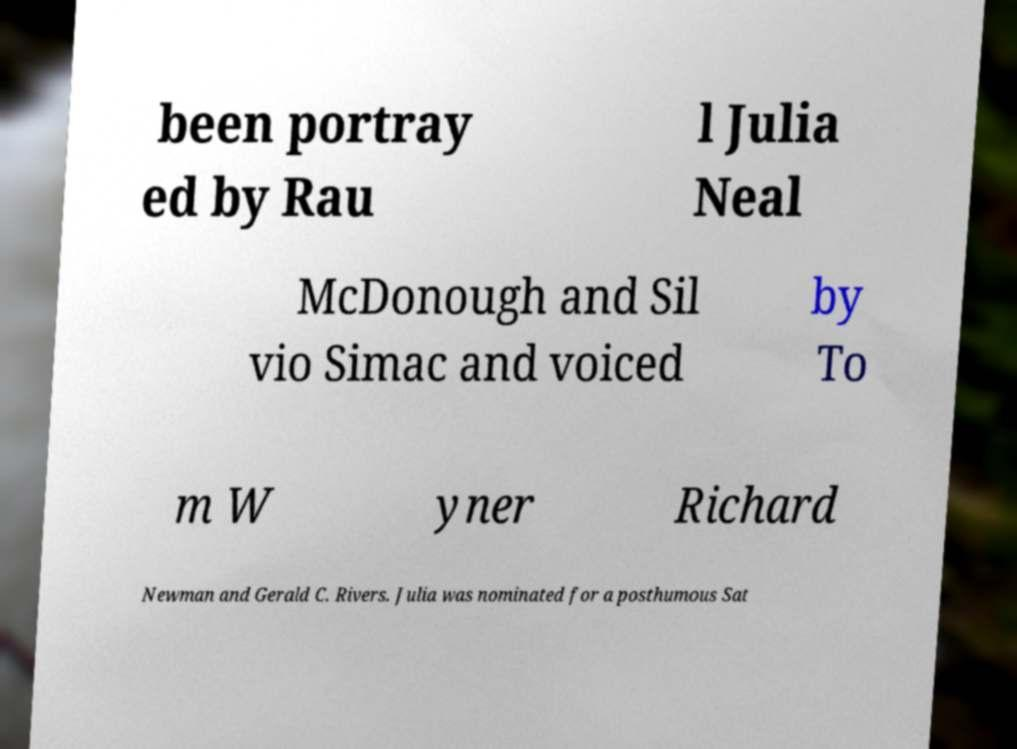Please read and relay the text visible in this image. What does it say? been portray ed by Rau l Julia Neal McDonough and Sil vio Simac and voiced by To m W yner Richard Newman and Gerald C. Rivers. Julia was nominated for a posthumous Sat 